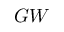Convert formula to latex. <formula><loc_0><loc_0><loc_500><loc_500>G W</formula> 